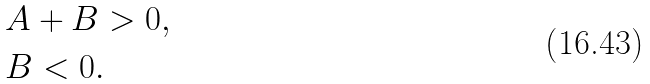Convert formula to latex. <formula><loc_0><loc_0><loc_500><loc_500>& A + B > 0 , \\ & B < 0 .</formula> 